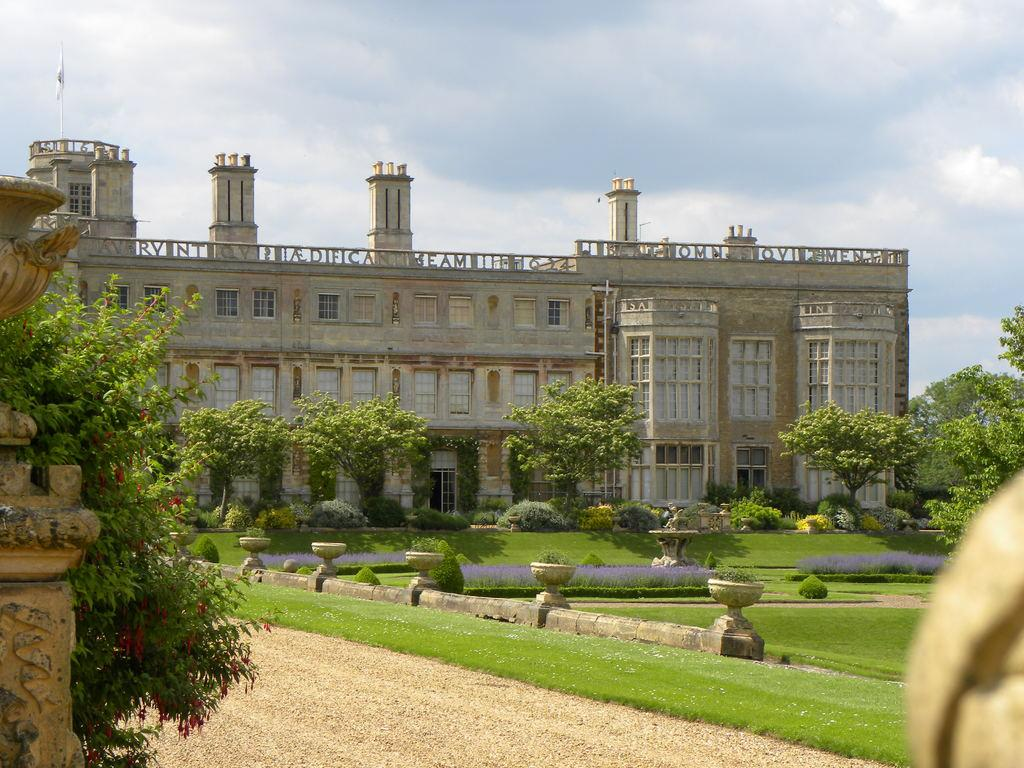What type of structures can be seen in the image? There are pillars and a stone building in the image. What type of vegetation is present in the image? There is grass, shrubs, and trees in the image. What is the condition of the sky in the background of the image? The sky in the background of the image is cloudy. Where is the tub located in the image? There is no tub present in the image. What type of stocking is hanging from the trees in the image? There are no stockings hanging from the trees in the image. 